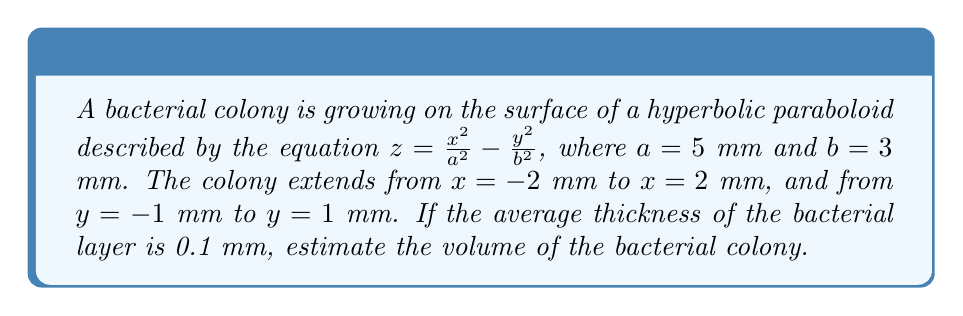Show me your answer to this math problem. To estimate the volume of the bacterial colony, we need to calculate the surface area of the hyperbolic paraboloid within the given bounds and multiply it by the thickness of the bacterial layer. Let's break this down step-by-step:

1) The surface area of a hyperbolic paraboloid is given by the formula:

   $$A = \int_{x_1}^{x_2} \int_{y_1}^{y_2} \sqrt{1 + (\frac{\partial z}{\partial x})^2 + (\frac{\partial z}{\partial y})^2} dy dx$$

2) Calculate the partial derivatives:
   $$\frac{\partial z}{\partial x} = \frac{2x}{a^2} = \frac{2x}{25}$$
   $$\frac{\partial z}{\partial y} = -\frac{2y}{b^2} = -\frac{2y}{9}$$

3) Substitute these into the surface area formula:

   $$A = \int_{-2}^{2} \int_{-1}^{1} \sqrt{1 + (\frac{2x}{25})^2 + (\frac{2y}{9})^2} dy dx$$

4) This integral is complex to solve analytically. We can use numerical integration methods or approximate it. For this estimation, let's use the average value of the integrand over the region:

   $$A \approx 4 \cdot 2 \cdot \sqrt{1 + (\frac{2\cdot1}{25})^2 + (\frac{2\cdot0.5}{9})^2} = 8 \cdot 1.0198 = 8.1584 \text{ mm}^2$$

5) Now, to find the volume, multiply the surface area by the thickness:

   $$V = A \cdot t = 8.1584 \cdot 0.1 = 0.81584 \text{ mm}^3$$

6) Rounding to two decimal places for the final estimate:

   $$V \approx 0.82 \text{ mm}^3$$
Answer: $0.82 \text{ mm}^3$ 